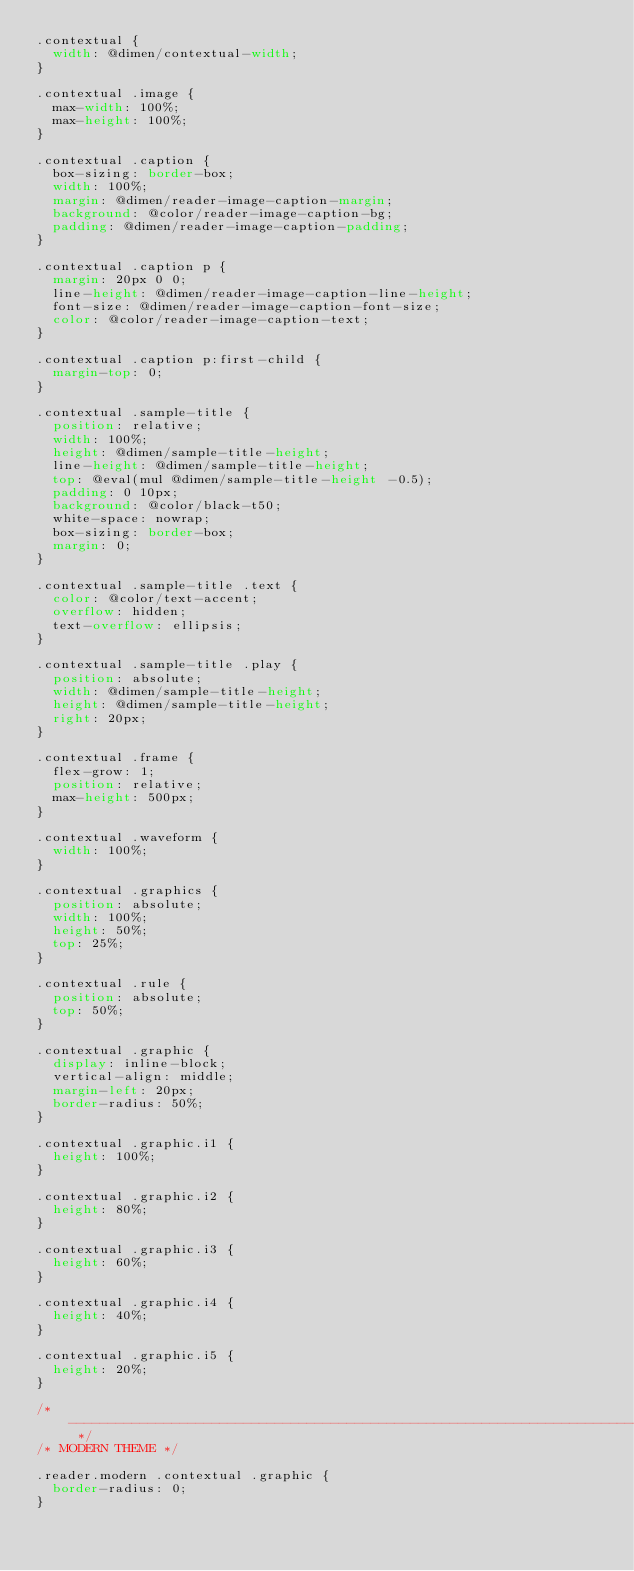<code> <loc_0><loc_0><loc_500><loc_500><_CSS_>.contextual {
	width: @dimen/contextual-width;
}

.contextual .image {
	max-width: 100%;
	max-height: 100%;
}

.contextual .caption {
	box-sizing: border-box;
	width: 100%;
	margin: @dimen/reader-image-caption-margin;
	background: @color/reader-image-caption-bg;
	padding: @dimen/reader-image-caption-padding;
} 

.contextual .caption p {
	margin: 20px 0 0;
	line-height: @dimen/reader-image-caption-line-height;
	font-size: @dimen/reader-image-caption-font-size;
	color: @color/reader-image-caption-text;
}

.contextual .caption p:first-child {
	margin-top: 0;
}

.contextual .sample-title {
	position: relative;
	width: 100%;
	height: @dimen/sample-title-height;
	line-height: @dimen/sample-title-height;
	top: @eval(mul @dimen/sample-title-height -0.5);	
	padding: 0 10px;
	background: @color/black-t50;	
	white-space: nowrap;
	box-sizing: border-box;
	margin: 0;
}

.contextual .sample-title .text {
	color: @color/text-accent;
	overflow: hidden;
	text-overflow: ellipsis;
}

.contextual .sample-title .play {
	position: absolute;
	width: @dimen/sample-title-height;
	height: @dimen/sample-title-height;
	right: 20px;
}

.contextual .frame {
	flex-grow: 1;
	position: relative;	
	max-height: 500px;
}

.contextual .waveform {
	width: 100%;
} 

.contextual .graphics {
	position: absolute;
	width: 100%;
	height: 50%;
	top: 25%;
} 
	
.contextual .rule {
	position: absolute;
	top: 50%;
}

.contextual .graphic {
	display: inline-block;
	vertical-align: middle;
	margin-left: 20px;
	border-radius: 50%;
}

.contextual .graphic.i1 {
	height: 100%;
}

.contextual .graphic.i2 {
	height: 80%;
}

.contextual .graphic.i3 {
	height: 60%;
}

.contextual .graphic.i4 {
	height: 40%;
}

.contextual .graphic.i5 {
	height: 20%;
}

/* --------------------------------------------------------------------------------------------- */
/* MODERN THEME */

.reader.modern .contextual .graphic {
	border-radius: 0;
}
</code> 